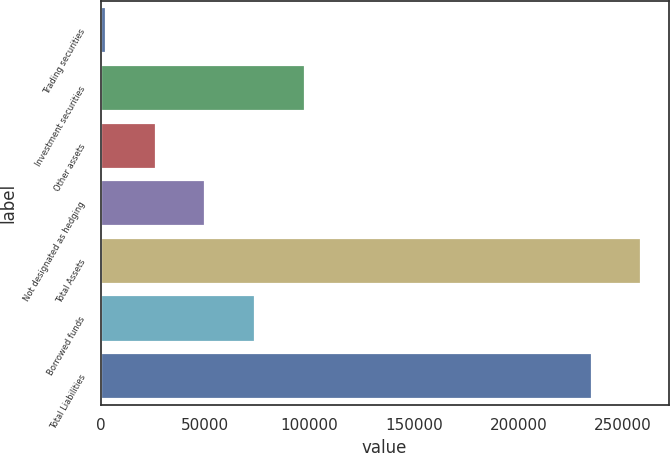<chart> <loc_0><loc_0><loc_500><loc_500><bar_chart><fcel>Trading securities<fcel>Investment securities<fcel>Other assets<fcel>Not designated as hedging<fcel>Total Assets<fcel>Borrowed funds<fcel>Total Liabilities<nl><fcel>2513<fcel>97829.4<fcel>26342.1<fcel>50171.2<fcel>258939<fcel>74000.3<fcel>235110<nl></chart> 